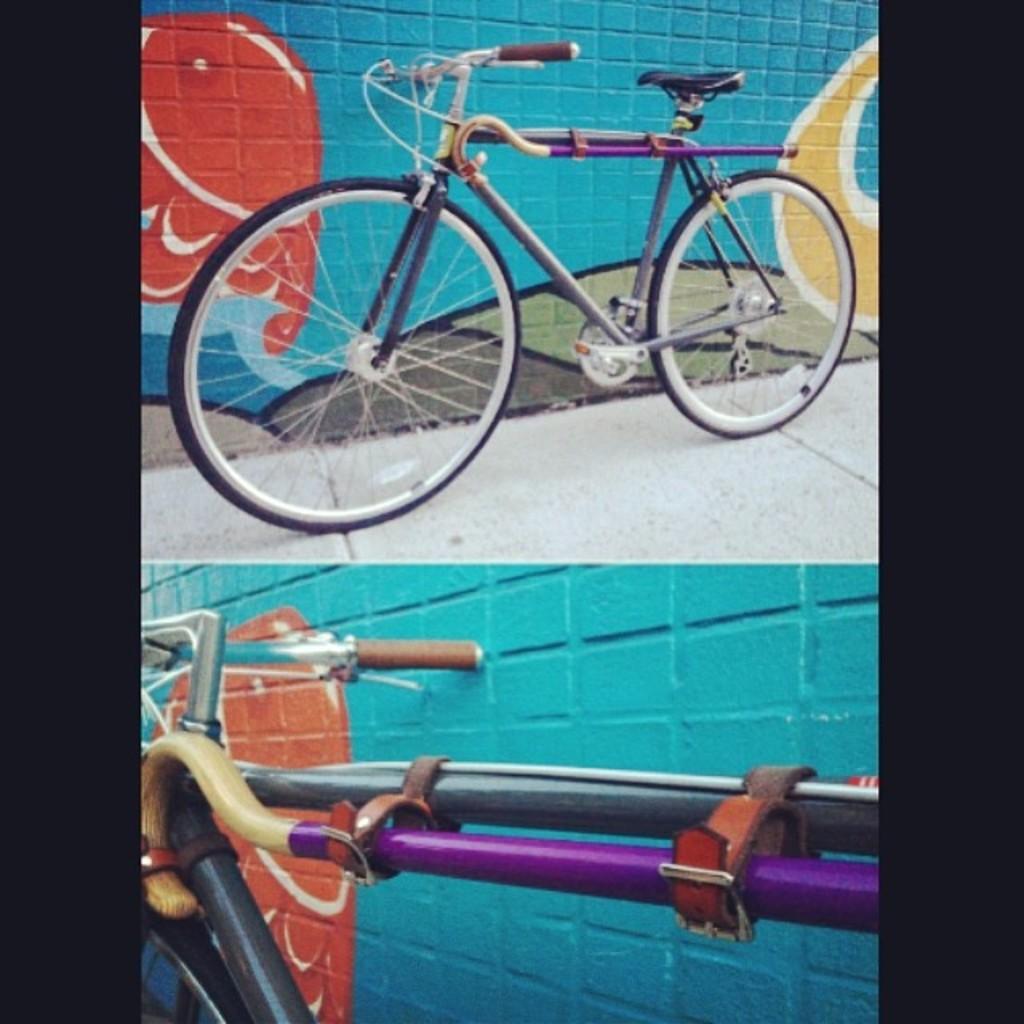Can you describe this image briefly? This is an edited image with the college of two images. At the top there is a bicycle placed on the ground. At the bottom we can see the metal rods and the handle of a bicycle. In the background we can see the art of graffiti on the walls. 